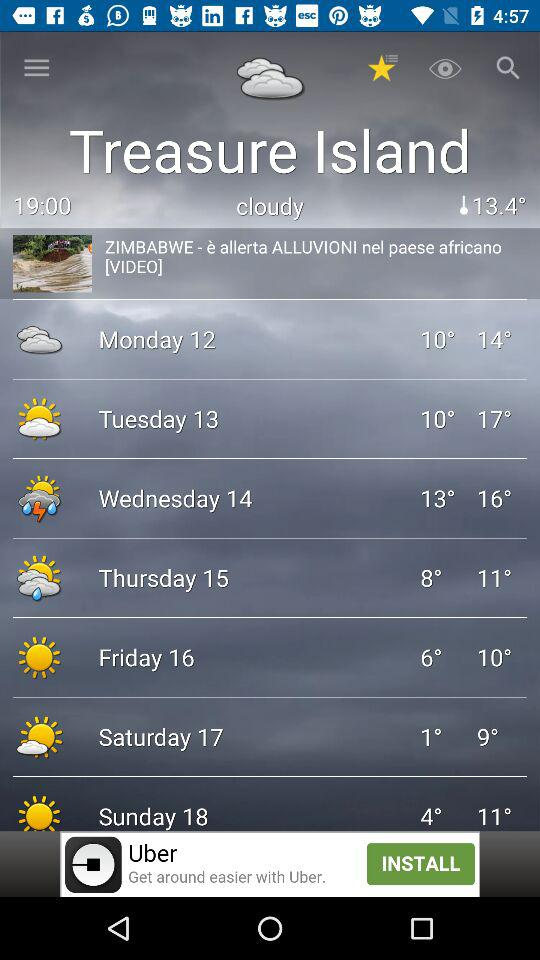How’s the weather on Monday? The weather on Monday is cloudy. 